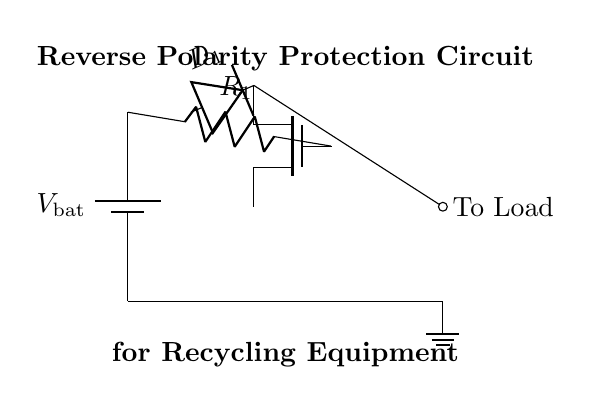What is the main purpose of this circuit? The purpose of this circuit is reverse polarity protection to prevent damage to the device when the battery is connected incorrectly. This is vital for rechargeable batteries in portable recycling equipment, ensuring the equipment operates safely.
Answer: Reverse polarity protection What component is used to control the current flow in this circuit? The NMOS transistor is the component controlling the current flow. It allows or blocks the current depending on the gate voltage, providing switch-like behavior in response to polarity.
Answer: NMOS transistor How many diodes are present in this circuit? There is one diode, labeled D1 in the circuit. It is positioned to allow current to flow in the correct direction while blocking it in the reverse direction, which is crucial for reverse polarity protection.
Answer: One What would happen if the battery is connected in reverse? If the battery is connected in reverse, the diode D1 will be reverse-biased, preventing current from flowing to the load and protecting the circuit from potential damage caused by the incorrect polarity.
Answer: Current will not flow What is the role of the resistor in this circuit? The resistor R1 serves as a pull-up or pull-down resistor, depending on its configuration, to ensure that the NMOS transistor operates correctly by providing a defined voltage level at the gate.
Answer: To control NMOS operation What is the label of the voltage source in this diagram? The voltage source in this circuit is labeled V bat, representing the battery voltage. This is important to identify the source providing power to the circuit and its associated loads.
Answer: V bat What happens to the load when the battery is connected correctly? When the battery is connected correctly, the NMOS transistor turns on, allowing current to flow from the battery through the load, which powers the recycling equipment effectively.
Answer: Load receives power 